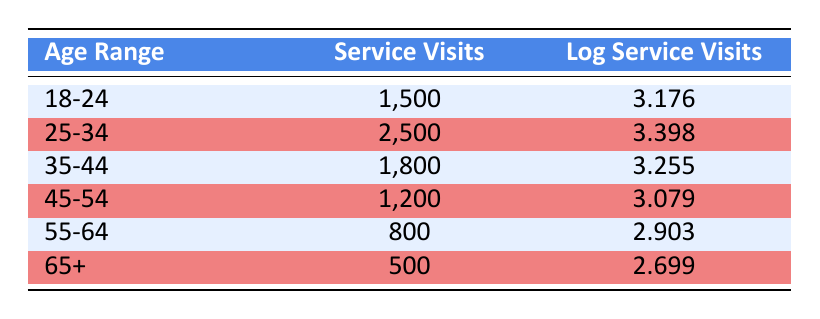What is the highest number of service visits recorded in the table? The table lists the following service visit counts: 1500, 2500, 1800, 1200, 800, and 500. Among these values, 2500 is the highest.
Answer: 2500 Which age group has the lowest number of service visits? Reviewing the service visit counts, the values are 1500, 2500, 1800, 1200, 800, and 500. The smallest value is 500, which corresponds to the age group "65+".
Answer: 65+ What is the log service visit value for the age group 55-64? From the table, the log service visit value for the age group "55-64" is specifically listed as 2.903.
Answer: 2.903 Calculate the average number of service visits across all age groups. The sum of the service visits is 1500 + 2500 + 1800 + 1200 + 800 + 500 = 8000. There are 6 age groups, so the average is 8000 / 6 ≈ 1333.33.
Answer: 1333.33 Is the number of service visits for the age group 45-54 greater than 1000? Checking the service visits for the age group "45-54," the count is 1200, which is indeed greater than 1000.
Answer: Yes Which age group experiences a significant decrease in telehealth usage compared to the age group 25-34? The age group "25-34" has 2500 service visits, while the next group, "35-44," has only 1800. Thus, the significant decrease is from 2500 to 1800, a difference of 700 visits, which indicates a decline in usage.
Answer: 35-44 Is there a noticeable trend of declining telehealth visits as the age groups increase? Observing the service visits: 2500 (25-34), 1800 (35-44), 1200 (45-54), 800 (55-64), and 500 (65+), suggests that as the age increases, the number of visits consistently decreases.
Answer: Yes What is the difference in log service visits between the age groups 18-24 and 55-64? The log service visit for "18-24" is 3.176 and for "55-64" is 2.903. Calculating the difference, 3.176 - 2.903 = 0.273 indicates that "18-24" has a higher log visit rate by this amount.
Answer: 0.273 